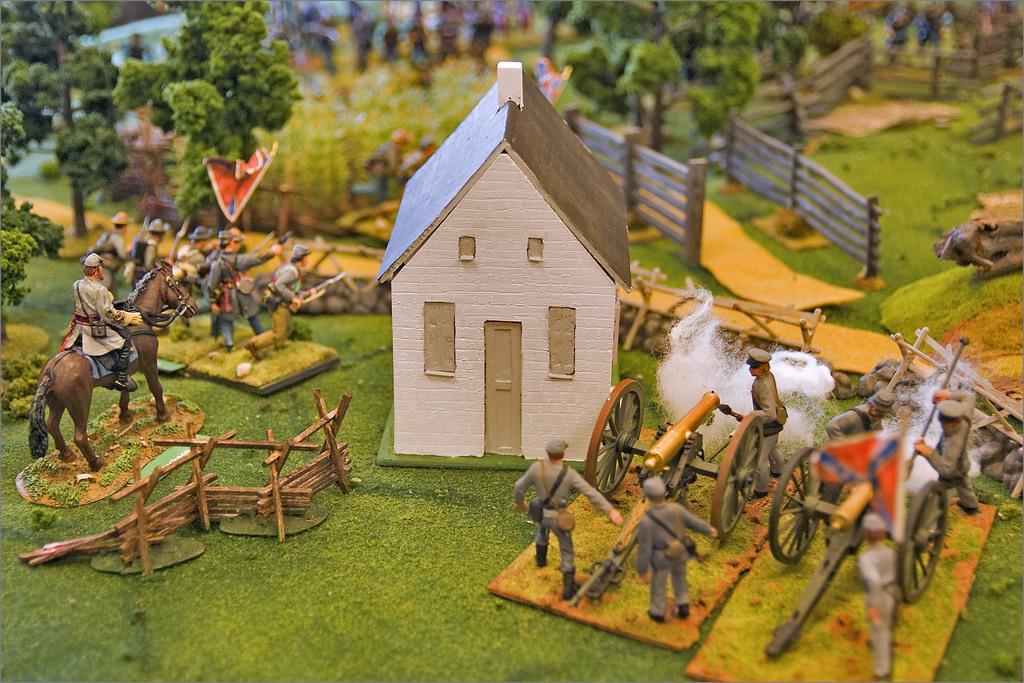Describe this image in one or two sentences. In this image we can see some toys. In that we can see a house with a roof, a group of people standing, some carts, the flag, wooden fence, a person riding a horse, grass and a group of trees. 